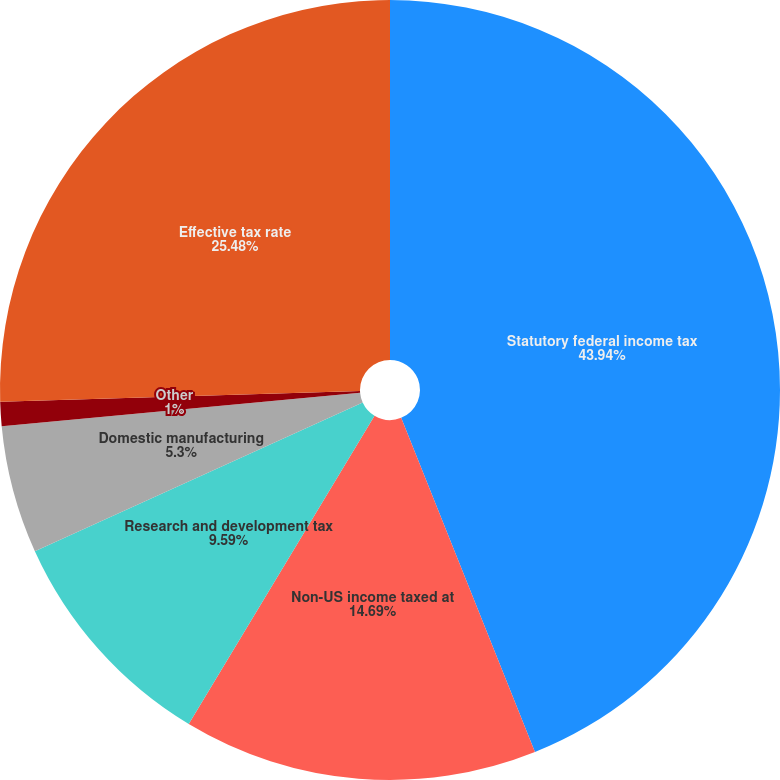Convert chart to OTSL. <chart><loc_0><loc_0><loc_500><loc_500><pie_chart><fcel>Statutory federal income tax<fcel>Non-US income taxed at<fcel>Research and development tax<fcel>Domestic manufacturing<fcel>Other<fcel>Effective tax rate<nl><fcel>43.94%<fcel>14.69%<fcel>9.59%<fcel>5.3%<fcel>1.0%<fcel>25.48%<nl></chart> 